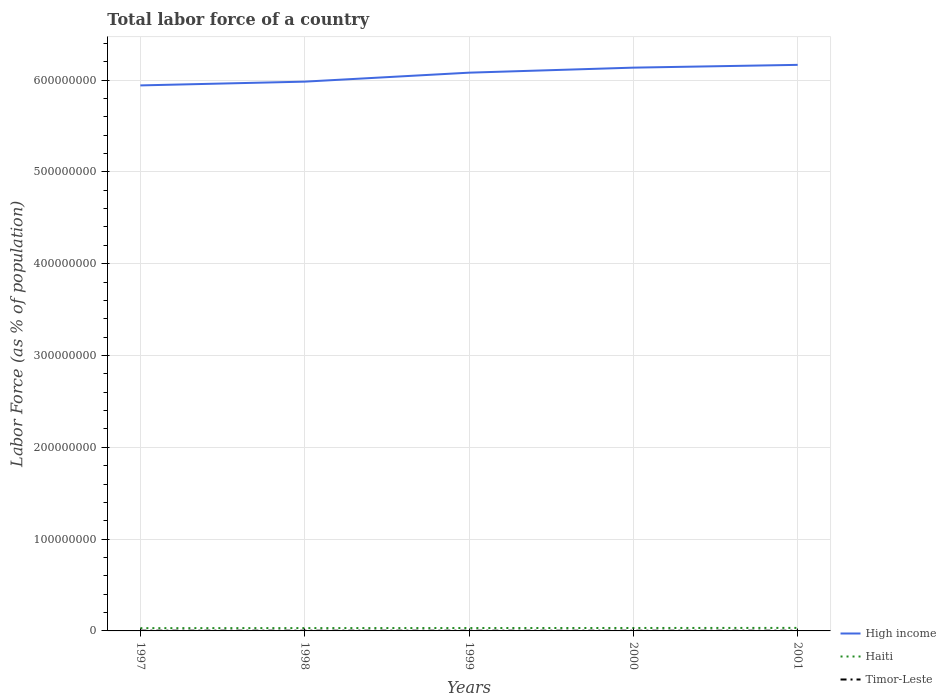Does the line corresponding to High income intersect with the line corresponding to Timor-Leste?
Keep it short and to the point. No. Is the number of lines equal to the number of legend labels?
Make the answer very short. Yes. Across all years, what is the maximum percentage of labor force in Timor-Leste?
Ensure brevity in your answer.  2.38e+05. What is the total percentage of labor force in High income in the graph?
Your response must be concise. -4.10e+06. What is the difference between the highest and the second highest percentage of labor force in Haiti?
Your answer should be compact. 2.64e+05. Is the percentage of labor force in Haiti strictly greater than the percentage of labor force in High income over the years?
Your answer should be very brief. Yes. How many years are there in the graph?
Your answer should be very brief. 5. What is the difference between two consecutive major ticks on the Y-axis?
Your answer should be compact. 1.00e+08. Are the values on the major ticks of Y-axis written in scientific E-notation?
Provide a succinct answer. No. Does the graph contain any zero values?
Your response must be concise. No. How many legend labels are there?
Offer a terse response. 3. How are the legend labels stacked?
Offer a terse response. Vertical. What is the title of the graph?
Your answer should be very brief. Total labor force of a country. Does "Bosnia and Herzegovina" appear as one of the legend labels in the graph?
Ensure brevity in your answer.  No. What is the label or title of the X-axis?
Give a very brief answer. Years. What is the label or title of the Y-axis?
Keep it short and to the point. Labor Force (as % of population). What is the Labor Force (as % of population) in High income in 1997?
Your response must be concise. 5.94e+08. What is the Labor Force (as % of population) of Haiti in 1997?
Offer a very short reply. 3.02e+06. What is the Labor Force (as % of population) of Timor-Leste in 1997?
Your response must be concise. 2.73e+05. What is the Labor Force (as % of population) in High income in 1998?
Make the answer very short. 5.98e+08. What is the Labor Force (as % of population) in Haiti in 1998?
Your response must be concise. 3.08e+06. What is the Labor Force (as % of population) of Timor-Leste in 1998?
Keep it short and to the point. 2.62e+05. What is the Labor Force (as % of population) of High income in 1999?
Give a very brief answer. 6.08e+08. What is the Labor Force (as % of population) of Haiti in 1999?
Your response must be concise. 3.14e+06. What is the Labor Force (as % of population) of Timor-Leste in 1999?
Make the answer very short. 2.50e+05. What is the Labor Force (as % of population) in High income in 2000?
Ensure brevity in your answer.  6.14e+08. What is the Labor Force (as % of population) of Haiti in 2000?
Make the answer very short. 3.20e+06. What is the Labor Force (as % of population) of Timor-Leste in 2000?
Your answer should be very brief. 2.38e+05. What is the Labor Force (as % of population) of High income in 2001?
Provide a short and direct response. 6.17e+08. What is the Labor Force (as % of population) in Haiti in 2001?
Keep it short and to the point. 3.29e+06. What is the Labor Force (as % of population) in Timor-Leste in 2001?
Give a very brief answer. 2.50e+05. Across all years, what is the maximum Labor Force (as % of population) of High income?
Provide a succinct answer. 6.17e+08. Across all years, what is the maximum Labor Force (as % of population) in Haiti?
Ensure brevity in your answer.  3.29e+06. Across all years, what is the maximum Labor Force (as % of population) of Timor-Leste?
Ensure brevity in your answer.  2.73e+05. Across all years, what is the minimum Labor Force (as % of population) in High income?
Make the answer very short. 5.94e+08. Across all years, what is the minimum Labor Force (as % of population) of Haiti?
Provide a short and direct response. 3.02e+06. Across all years, what is the minimum Labor Force (as % of population) of Timor-Leste?
Offer a terse response. 2.38e+05. What is the total Labor Force (as % of population) in High income in the graph?
Offer a terse response. 3.03e+09. What is the total Labor Force (as % of population) of Haiti in the graph?
Make the answer very short. 1.57e+07. What is the total Labor Force (as % of population) in Timor-Leste in the graph?
Your answer should be compact. 1.27e+06. What is the difference between the Labor Force (as % of population) in High income in 1997 and that in 1998?
Your answer should be very brief. -4.10e+06. What is the difference between the Labor Force (as % of population) in Haiti in 1997 and that in 1998?
Make the answer very short. -5.66e+04. What is the difference between the Labor Force (as % of population) of Timor-Leste in 1997 and that in 1998?
Keep it short and to the point. 1.02e+04. What is the difference between the Labor Force (as % of population) in High income in 1997 and that in 1999?
Provide a short and direct response. -1.39e+07. What is the difference between the Labor Force (as % of population) in Haiti in 1997 and that in 1999?
Ensure brevity in your answer.  -1.19e+05. What is the difference between the Labor Force (as % of population) of Timor-Leste in 1997 and that in 1999?
Your response must be concise. 2.26e+04. What is the difference between the Labor Force (as % of population) of High income in 1997 and that in 2000?
Provide a succinct answer. -1.93e+07. What is the difference between the Labor Force (as % of population) of Haiti in 1997 and that in 2000?
Your response must be concise. -1.80e+05. What is the difference between the Labor Force (as % of population) of Timor-Leste in 1997 and that in 2000?
Your response must be concise. 3.43e+04. What is the difference between the Labor Force (as % of population) of High income in 1997 and that in 2001?
Give a very brief answer. -2.24e+07. What is the difference between the Labor Force (as % of population) in Haiti in 1997 and that in 2001?
Your answer should be very brief. -2.64e+05. What is the difference between the Labor Force (as % of population) of Timor-Leste in 1997 and that in 2001?
Ensure brevity in your answer.  2.25e+04. What is the difference between the Labor Force (as % of population) in High income in 1998 and that in 1999?
Provide a succinct answer. -9.76e+06. What is the difference between the Labor Force (as % of population) of Haiti in 1998 and that in 1999?
Offer a very short reply. -6.21e+04. What is the difference between the Labor Force (as % of population) in Timor-Leste in 1998 and that in 1999?
Make the answer very short. 1.23e+04. What is the difference between the Labor Force (as % of population) in High income in 1998 and that in 2000?
Your answer should be very brief. -1.52e+07. What is the difference between the Labor Force (as % of population) in Haiti in 1998 and that in 2000?
Keep it short and to the point. -1.23e+05. What is the difference between the Labor Force (as % of population) of Timor-Leste in 1998 and that in 2000?
Provide a succinct answer. 2.40e+04. What is the difference between the Labor Force (as % of population) of High income in 1998 and that in 2001?
Provide a succinct answer. -1.83e+07. What is the difference between the Labor Force (as % of population) in Haiti in 1998 and that in 2001?
Provide a short and direct response. -2.07e+05. What is the difference between the Labor Force (as % of population) in Timor-Leste in 1998 and that in 2001?
Your answer should be very brief. 1.23e+04. What is the difference between the Labor Force (as % of population) in High income in 1999 and that in 2000?
Provide a succinct answer. -5.49e+06. What is the difference between the Labor Force (as % of population) of Haiti in 1999 and that in 2000?
Offer a very short reply. -6.12e+04. What is the difference between the Labor Force (as % of population) of Timor-Leste in 1999 and that in 2000?
Provide a succinct answer. 1.17e+04. What is the difference between the Labor Force (as % of population) of High income in 1999 and that in 2001?
Offer a very short reply. -8.51e+06. What is the difference between the Labor Force (as % of population) in Haiti in 1999 and that in 2001?
Your response must be concise. -1.45e+05. What is the difference between the Labor Force (as % of population) of Timor-Leste in 1999 and that in 2001?
Your response must be concise. -9. What is the difference between the Labor Force (as % of population) in High income in 2000 and that in 2001?
Your response must be concise. -3.02e+06. What is the difference between the Labor Force (as % of population) of Haiti in 2000 and that in 2001?
Provide a short and direct response. -8.40e+04. What is the difference between the Labor Force (as % of population) in Timor-Leste in 2000 and that in 2001?
Give a very brief answer. -1.17e+04. What is the difference between the Labor Force (as % of population) in High income in 1997 and the Labor Force (as % of population) in Haiti in 1998?
Provide a short and direct response. 5.91e+08. What is the difference between the Labor Force (as % of population) of High income in 1997 and the Labor Force (as % of population) of Timor-Leste in 1998?
Give a very brief answer. 5.94e+08. What is the difference between the Labor Force (as % of population) in Haiti in 1997 and the Labor Force (as % of population) in Timor-Leste in 1998?
Keep it short and to the point. 2.76e+06. What is the difference between the Labor Force (as % of population) in High income in 1997 and the Labor Force (as % of population) in Haiti in 1999?
Provide a succinct answer. 5.91e+08. What is the difference between the Labor Force (as % of population) in High income in 1997 and the Labor Force (as % of population) in Timor-Leste in 1999?
Give a very brief answer. 5.94e+08. What is the difference between the Labor Force (as % of population) in Haiti in 1997 and the Labor Force (as % of population) in Timor-Leste in 1999?
Keep it short and to the point. 2.77e+06. What is the difference between the Labor Force (as % of population) of High income in 1997 and the Labor Force (as % of population) of Haiti in 2000?
Provide a short and direct response. 5.91e+08. What is the difference between the Labor Force (as % of population) of High income in 1997 and the Labor Force (as % of population) of Timor-Leste in 2000?
Offer a terse response. 5.94e+08. What is the difference between the Labor Force (as % of population) of Haiti in 1997 and the Labor Force (as % of population) of Timor-Leste in 2000?
Your response must be concise. 2.79e+06. What is the difference between the Labor Force (as % of population) of High income in 1997 and the Labor Force (as % of population) of Haiti in 2001?
Keep it short and to the point. 5.91e+08. What is the difference between the Labor Force (as % of population) of High income in 1997 and the Labor Force (as % of population) of Timor-Leste in 2001?
Your answer should be very brief. 5.94e+08. What is the difference between the Labor Force (as % of population) in Haiti in 1997 and the Labor Force (as % of population) in Timor-Leste in 2001?
Ensure brevity in your answer.  2.77e+06. What is the difference between the Labor Force (as % of population) of High income in 1998 and the Labor Force (as % of population) of Haiti in 1999?
Your answer should be compact. 5.95e+08. What is the difference between the Labor Force (as % of population) of High income in 1998 and the Labor Force (as % of population) of Timor-Leste in 1999?
Make the answer very short. 5.98e+08. What is the difference between the Labor Force (as % of population) in Haiti in 1998 and the Labor Force (as % of population) in Timor-Leste in 1999?
Make the answer very short. 2.83e+06. What is the difference between the Labor Force (as % of population) in High income in 1998 and the Labor Force (as % of population) in Haiti in 2000?
Provide a short and direct response. 5.95e+08. What is the difference between the Labor Force (as % of population) in High income in 1998 and the Labor Force (as % of population) in Timor-Leste in 2000?
Provide a short and direct response. 5.98e+08. What is the difference between the Labor Force (as % of population) of Haiti in 1998 and the Labor Force (as % of population) of Timor-Leste in 2000?
Offer a very short reply. 2.84e+06. What is the difference between the Labor Force (as % of population) in High income in 1998 and the Labor Force (as % of population) in Haiti in 2001?
Offer a very short reply. 5.95e+08. What is the difference between the Labor Force (as % of population) of High income in 1998 and the Labor Force (as % of population) of Timor-Leste in 2001?
Your response must be concise. 5.98e+08. What is the difference between the Labor Force (as % of population) of Haiti in 1998 and the Labor Force (as % of population) of Timor-Leste in 2001?
Your answer should be compact. 2.83e+06. What is the difference between the Labor Force (as % of population) in High income in 1999 and the Labor Force (as % of population) in Haiti in 2000?
Make the answer very short. 6.05e+08. What is the difference between the Labor Force (as % of population) in High income in 1999 and the Labor Force (as % of population) in Timor-Leste in 2000?
Provide a short and direct response. 6.08e+08. What is the difference between the Labor Force (as % of population) of Haiti in 1999 and the Labor Force (as % of population) of Timor-Leste in 2000?
Offer a very short reply. 2.90e+06. What is the difference between the Labor Force (as % of population) of High income in 1999 and the Labor Force (as % of population) of Haiti in 2001?
Provide a short and direct response. 6.05e+08. What is the difference between the Labor Force (as % of population) of High income in 1999 and the Labor Force (as % of population) of Timor-Leste in 2001?
Make the answer very short. 6.08e+08. What is the difference between the Labor Force (as % of population) in Haiti in 1999 and the Labor Force (as % of population) in Timor-Leste in 2001?
Make the answer very short. 2.89e+06. What is the difference between the Labor Force (as % of population) of High income in 2000 and the Labor Force (as % of population) of Haiti in 2001?
Offer a very short reply. 6.10e+08. What is the difference between the Labor Force (as % of population) of High income in 2000 and the Labor Force (as % of population) of Timor-Leste in 2001?
Keep it short and to the point. 6.13e+08. What is the difference between the Labor Force (as % of population) of Haiti in 2000 and the Labor Force (as % of population) of Timor-Leste in 2001?
Keep it short and to the point. 2.95e+06. What is the average Labor Force (as % of population) of High income per year?
Your answer should be very brief. 6.06e+08. What is the average Labor Force (as % of population) in Haiti per year?
Your answer should be compact. 3.15e+06. What is the average Labor Force (as % of population) of Timor-Leste per year?
Provide a short and direct response. 2.55e+05. In the year 1997, what is the difference between the Labor Force (as % of population) of High income and Labor Force (as % of population) of Haiti?
Offer a terse response. 5.91e+08. In the year 1997, what is the difference between the Labor Force (as % of population) of High income and Labor Force (as % of population) of Timor-Leste?
Ensure brevity in your answer.  5.94e+08. In the year 1997, what is the difference between the Labor Force (as % of population) in Haiti and Labor Force (as % of population) in Timor-Leste?
Make the answer very short. 2.75e+06. In the year 1998, what is the difference between the Labor Force (as % of population) of High income and Labor Force (as % of population) of Haiti?
Ensure brevity in your answer.  5.95e+08. In the year 1998, what is the difference between the Labor Force (as % of population) of High income and Labor Force (as % of population) of Timor-Leste?
Keep it short and to the point. 5.98e+08. In the year 1998, what is the difference between the Labor Force (as % of population) of Haiti and Labor Force (as % of population) of Timor-Leste?
Make the answer very short. 2.82e+06. In the year 1999, what is the difference between the Labor Force (as % of population) in High income and Labor Force (as % of population) in Haiti?
Offer a terse response. 6.05e+08. In the year 1999, what is the difference between the Labor Force (as % of population) of High income and Labor Force (as % of population) of Timor-Leste?
Your answer should be very brief. 6.08e+08. In the year 1999, what is the difference between the Labor Force (as % of population) in Haiti and Labor Force (as % of population) in Timor-Leste?
Your answer should be compact. 2.89e+06. In the year 2000, what is the difference between the Labor Force (as % of population) of High income and Labor Force (as % of population) of Haiti?
Provide a succinct answer. 6.10e+08. In the year 2000, what is the difference between the Labor Force (as % of population) in High income and Labor Force (as % of population) in Timor-Leste?
Offer a terse response. 6.13e+08. In the year 2000, what is the difference between the Labor Force (as % of population) in Haiti and Labor Force (as % of population) in Timor-Leste?
Offer a terse response. 2.97e+06. In the year 2001, what is the difference between the Labor Force (as % of population) of High income and Labor Force (as % of population) of Haiti?
Your response must be concise. 6.13e+08. In the year 2001, what is the difference between the Labor Force (as % of population) of High income and Labor Force (as % of population) of Timor-Leste?
Keep it short and to the point. 6.16e+08. In the year 2001, what is the difference between the Labor Force (as % of population) in Haiti and Labor Force (as % of population) in Timor-Leste?
Provide a short and direct response. 3.04e+06. What is the ratio of the Labor Force (as % of population) in Haiti in 1997 to that in 1998?
Provide a succinct answer. 0.98. What is the ratio of the Labor Force (as % of population) in Timor-Leste in 1997 to that in 1998?
Keep it short and to the point. 1.04. What is the ratio of the Labor Force (as % of population) in High income in 1997 to that in 1999?
Provide a succinct answer. 0.98. What is the ratio of the Labor Force (as % of population) of Haiti in 1997 to that in 1999?
Provide a short and direct response. 0.96. What is the ratio of the Labor Force (as % of population) of Timor-Leste in 1997 to that in 1999?
Provide a short and direct response. 1.09. What is the ratio of the Labor Force (as % of population) in High income in 1997 to that in 2000?
Ensure brevity in your answer.  0.97. What is the ratio of the Labor Force (as % of population) of Haiti in 1997 to that in 2000?
Provide a succinct answer. 0.94. What is the ratio of the Labor Force (as % of population) in Timor-Leste in 1997 to that in 2000?
Offer a very short reply. 1.14. What is the ratio of the Labor Force (as % of population) of High income in 1997 to that in 2001?
Provide a succinct answer. 0.96. What is the ratio of the Labor Force (as % of population) in Haiti in 1997 to that in 2001?
Your answer should be very brief. 0.92. What is the ratio of the Labor Force (as % of population) of Timor-Leste in 1997 to that in 2001?
Make the answer very short. 1.09. What is the ratio of the Labor Force (as % of population) of Haiti in 1998 to that in 1999?
Keep it short and to the point. 0.98. What is the ratio of the Labor Force (as % of population) in Timor-Leste in 1998 to that in 1999?
Provide a succinct answer. 1.05. What is the ratio of the Labor Force (as % of population) in High income in 1998 to that in 2000?
Ensure brevity in your answer.  0.98. What is the ratio of the Labor Force (as % of population) in Haiti in 1998 to that in 2000?
Your answer should be compact. 0.96. What is the ratio of the Labor Force (as % of population) of Timor-Leste in 1998 to that in 2000?
Your answer should be compact. 1.1. What is the ratio of the Labor Force (as % of population) of High income in 1998 to that in 2001?
Give a very brief answer. 0.97. What is the ratio of the Labor Force (as % of population) in Haiti in 1998 to that in 2001?
Offer a very short reply. 0.94. What is the ratio of the Labor Force (as % of population) of Timor-Leste in 1998 to that in 2001?
Offer a very short reply. 1.05. What is the ratio of the Labor Force (as % of population) of Haiti in 1999 to that in 2000?
Provide a succinct answer. 0.98. What is the ratio of the Labor Force (as % of population) in Timor-Leste in 1999 to that in 2000?
Keep it short and to the point. 1.05. What is the ratio of the Labor Force (as % of population) in High income in 1999 to that in 2001?
Your answer should be very brief. 0.99. What is the ratio of the Labor Force (as % of population) in Haiti in 1999 to that in 2001?
Make the answer very short. 0.96. What is the ratio of the Labor Force (as % of population) in Timor-Leste in 1999 to that in 2001?
Offer a terse response. 1. What is the ratio of the Labor Force (as % of population) in Haiti in 2000 to that in 2001?
Offer a very short reply. 0.97. What is the ratio of the Labor Force (as % of population) in Timor-Leste in 2000 to that in 2001?
Give a very brief answer. 0.95. What is the difference between the highest and the second highest Labor Force (as % of population) of High income?
Your response must be concise. 3.02e+06. What is the difference between the highest and the second highest Labor Force (as % of population) of Haiti?
Provide a succinct answer. 8.40e+04. What is the difference between the highest and the second highest Labor Force (as % of population) in Timor-Leste?
Your answer should be very brief. 1.02e+04. What is the difference between the highest and the lowest Labor Force (as % of population) in High income?
Give a very brief answer. 2.24e+07. What is the difference between the highest and the lowest Labor Force (as % of population) of Haiti?
Provide a succinct answer. 2.64e+05. What is the difference between the highest and the lowest Labor Force (as % of population) in Timor-Leste?
Make the answer very short. 3.43e+04. 